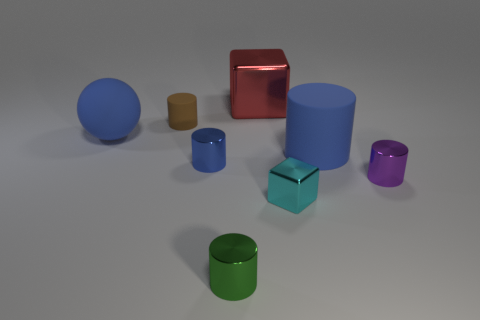Subtract all blue blocks. How many blue cylinders are left? 2 Subtract all small brown cylinders. How many cylinders are left? 4 Add 2 tiny purple metal blocks. How many objects exist? 10 Subtract all green cylinders. How many cylinders are left? 4 Subtract 2 cylinders. How many cylinders are left? 3 Subtract all cyan cylinders. Subtract all blue cubes. How many cylinders are left? 5 Add 6 tiny green shiny cylinders. How many tiny green shiny cylinders are left? 7 Add 8 big red objects. How many big red objects exist? 9 Subtract 1 red cubes. How many objects are left? 7 Subtract all balls. How many objects are left? 7 